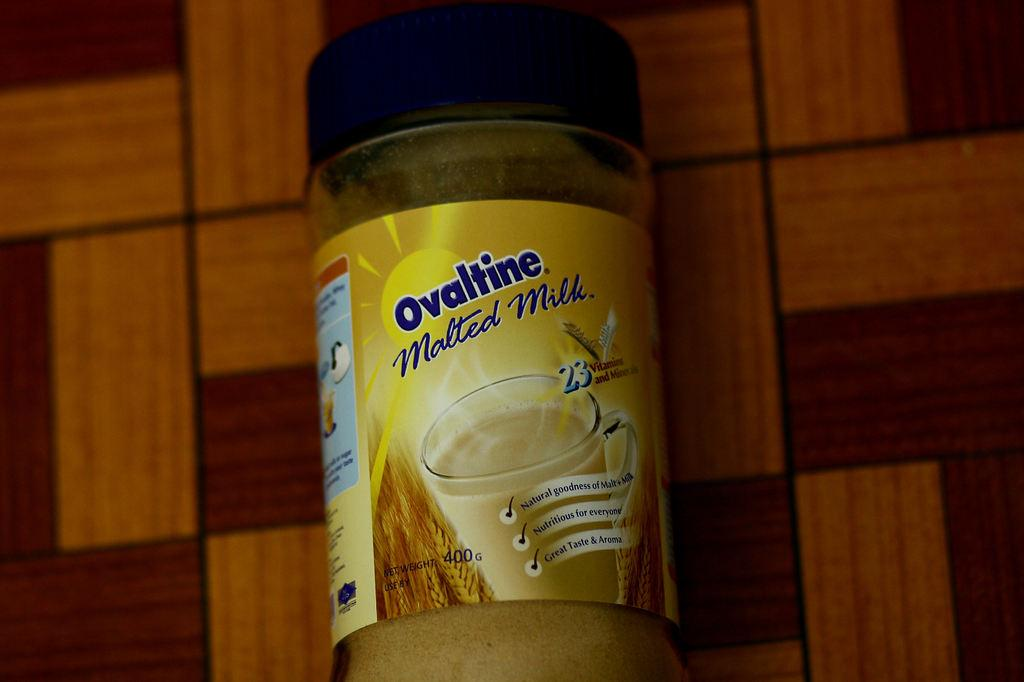<image>
Offer a succinct explanation of the picture presented. A bottle of Ovaltine malted milk sits on a two-tone wood table. 